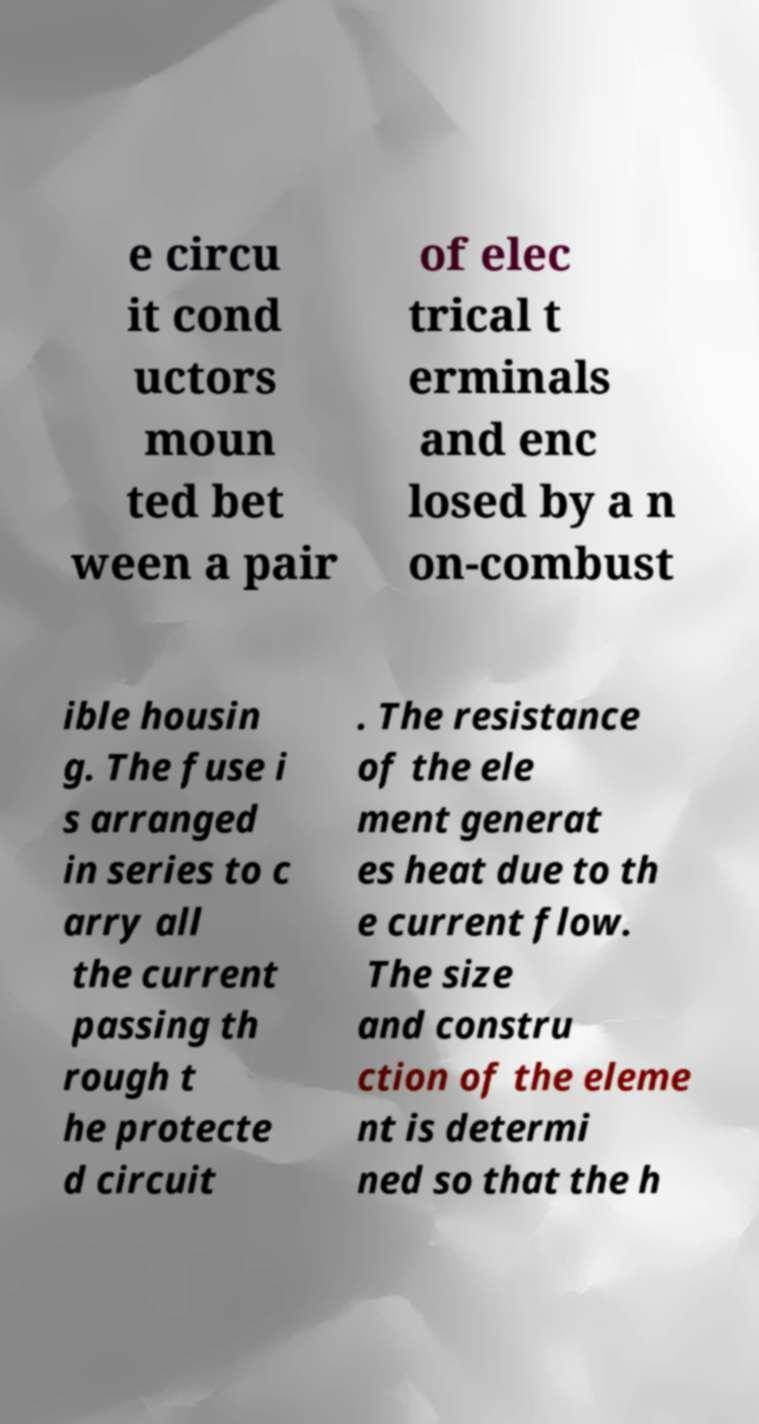There's text embedded in this image that I need extracted. Can you transcribe it verbatim? e circu it cond uctors moun ted bet ween a pair of elec trical t erminals and enc losed by a n on-combust ible housin g. The fuse i s arranged in series to c arry all the current passing th rough t he protecte d circuit . The resistance of the ele ment generat es heat due to th e current flow. The size and constru ction of the eleme nt is determi ned so that the h 